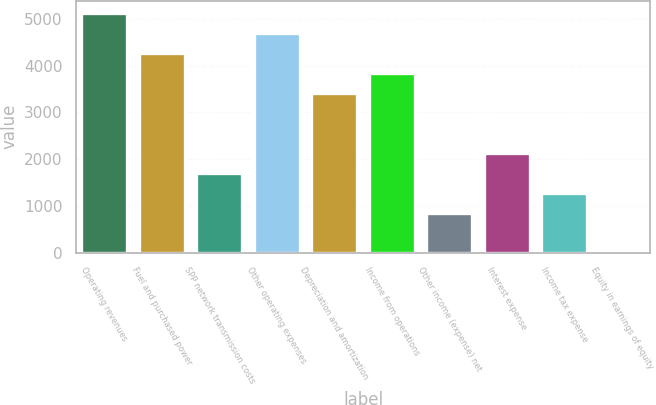<chart> <loc_0><loc_0><loc_500><loc_500><bar_chart><fcel>Operating revenues<fcel>Fuel and purchased power<fcel>SPP network transmission costs<fcel>Other operating expenses<fcel>Depreciation and amortization<fcel>Income from operations<fcel>Other income (expense) net<fcel>Interest expense<fcel>Income tax expense<fcel>Equity in earnings of equity<nl><fcel>5130<fcel>4275.9<fcel>1713.6<fcel>4702.95<fcel>3421.8<fcel>3848.85<fcel>859.5<fcel>2140.65<fcel>1286.55<fcel>5.4<nl></chart> 